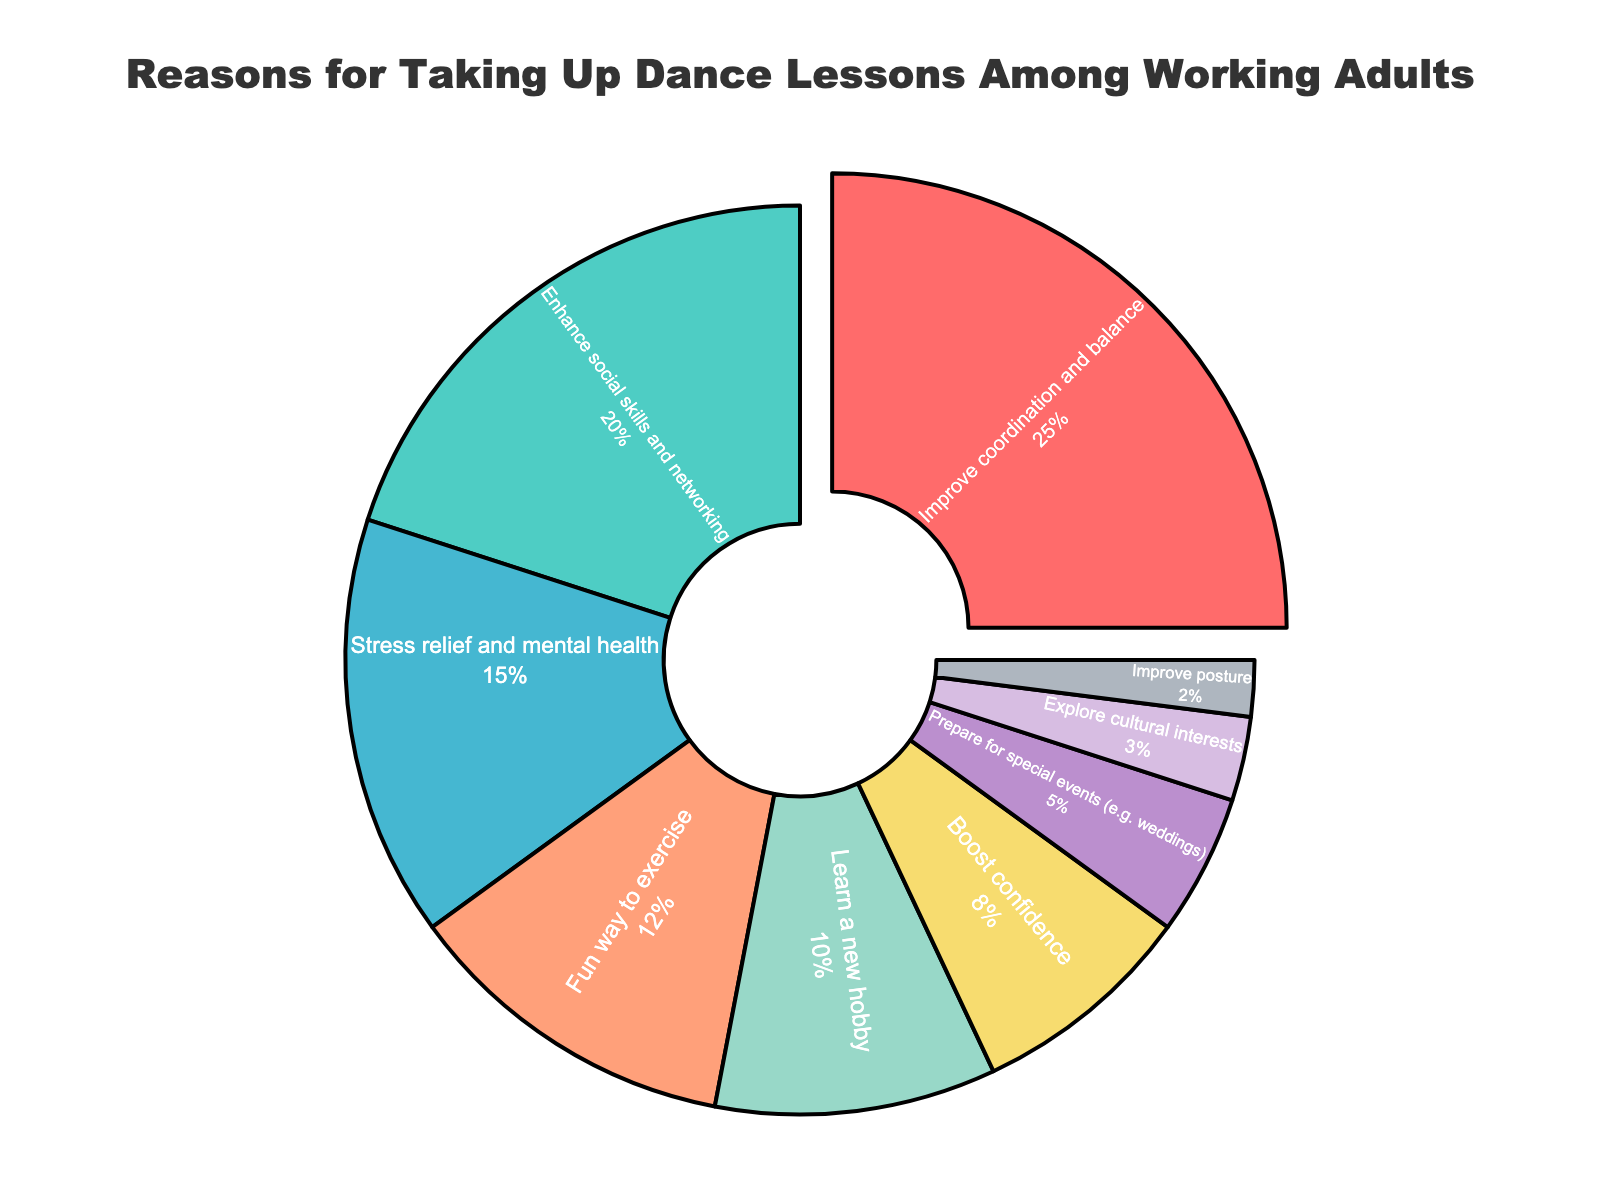Which reason has the largest percentage for taking up dance lessons? To find the reason with the largest percentage, look for the segment in the pie chart that occupies the most space.
Answer: Improve coordination and balance What two reasons together account for the largest percentage? To find the combined percentage of two reasons, add the percentages of the highest-ranked reasons: 25% for Improve coordination and balance and 20% for Enhance social skills and networking, yielding 45%.
Answer: Improve coordination and balance and Enhance social skills and networking What's the difference in percentage between the reasons related to social enhancement and stress relief? The percentage for Enhance social skills and networking is 20%, and Stress relief and mental health is 15%. Subtract 15% from 20% for the difference.
Answer: 5% Which reason has the lowest percentage? Look for the smallest segment in the pie chart, which represents the lowest percentage.
Answer: Improve posture How many reasons combine to account for at least 50% of the pie chart? Combine the percentages starting from the largest until the sum reaches or exceeds 50%: 25% + 20% = 45%, and adding 15% yields 60%. Thus, three reasons account for over 50%.
Answer: 3 Which two reasons have a combined percentage equal to that for Enhancing social skills and networking? Find two reasons whose sums equal 20%: Fun way to exercise (12%) + Learn a new hobby (10%) equals 22%, while Boost confidence (8%) + Prepare for special events (5%) equals 13%. Only Fun way to exercise and Learn a new hobby have a sum closest to 20%.
Answer: Fun way to exercise and Learn a new hobby How does the percentage for preparing for special events compare to exploring cultural interests? Preparing for special events has a percentage of 5%, while exploring cultural interests has 3%. Compare these values directly.
Answer: Greater What percentage is labeled with the color red? Identify the segment colored red in the pie chart and note its corresponding percentage value, which is 25%.
Answer: 25% What's the total percentage for all reasons related to health and wellness? Combine the percentages for Stress relief and mental health (15%) and Improve posture (2%), yielding a total of 17%.
Answer: 17% 